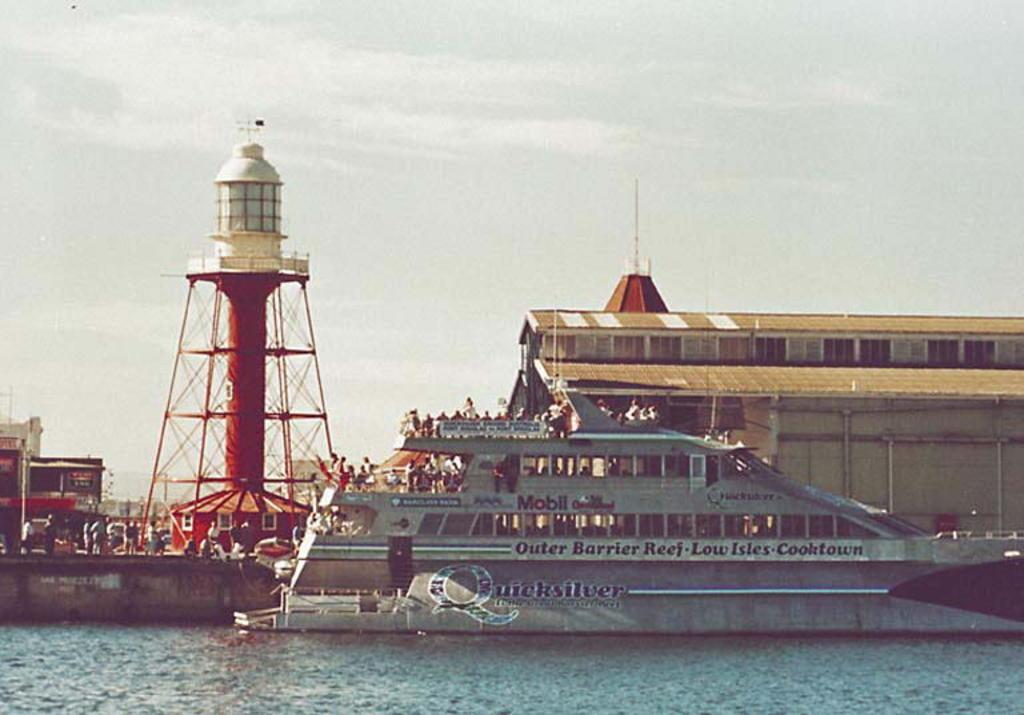<image>
Summarize the visual content of the image. A tour boat will take passengers to the Outer Barrier Reef. 